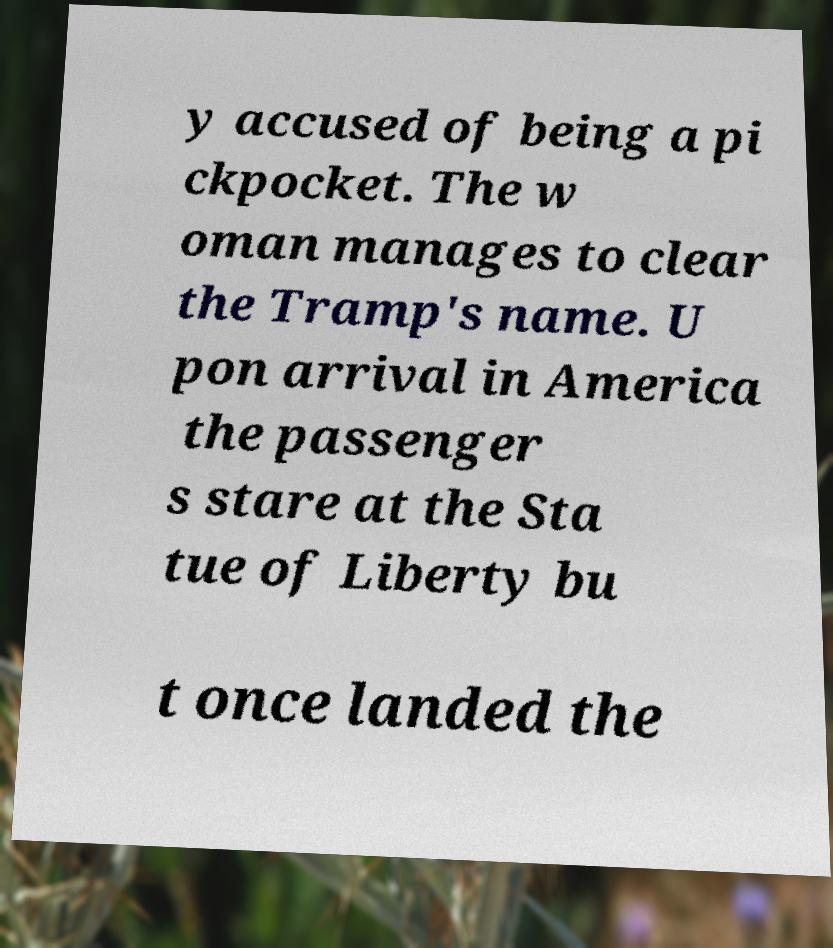Please identify and transcribe the text found in this image. y accused of being a pi ckpocket. The w oman manages to clear the Tramp's name. U pon arrival in America the passenger s stare at the Sta tue of Liberty bu t once landed the 